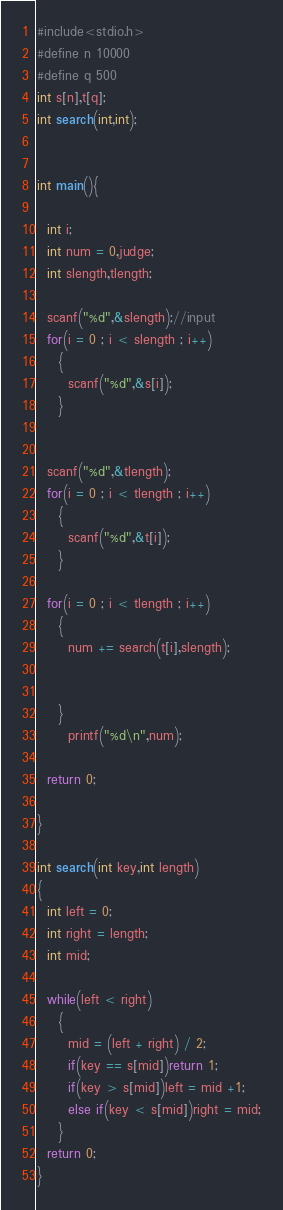<code> <loc_0><loc_0><loc_500><loc_500><_C_>#include<stdio.h>
#define n 10000
#define q 500
int s[n],t[q];
int search(int,int);


int main(){

  int i;
  int num = 0,judge;
  int slength,tlength;

  scanf("%d",&slength);//input
  for(i = 0 ; i < slength ; i++)
    {
      scanf("%d",&s[i]);
    }


  scanf("%d",&tlength);
  for(i = 0 ; i < tlength ; i++)
    {
      scanf("%d",&t[i]);
    }

  for(i = 0 ; i < tlength ; i++)
    {
      num += search(t[i],slength);


    }
      printf("%d\n",num);

  return 0;

}

int search(int key,int length)
{
  int left = 0;
  int right = length;
  int mid;

  while(left < right)
    {
      mid = (left + right) / 2;
      if(key == s[mid])return 1;
      if(key > s[mid])left = mid +1;
      else if(key < s[mid])right = mid;
    }
  return 0;
}</code> 